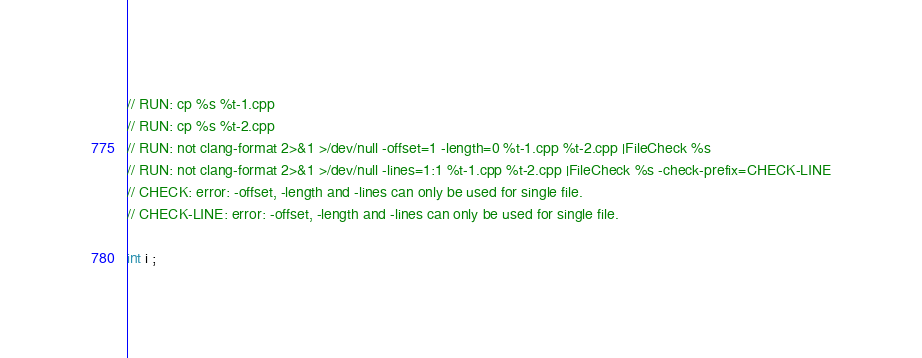Convert code to text. <code><loc_0><loc_0><loc_500><loc_500><_C++_>// RUN: cp %s %t-1.cpp
// RUN: cp %s %t-2.cpp
// RUN: not clang-format 2>&1 >/dev/null -offset=1 -length=0 %t-1.cpp %t-2.cpp |FileCheck %s
// RUN: not clang-format 2>&1 >/dev/null -lines=1:1 %t-1.cpp %t-2.cpp |FileCheck %s -check-prefix=CHECK-LINE
// CHECK: error: -offset, -length and -lines can only be used for single file.
// CHECK-LINE: error: -offset, -length and -lines can only be used for single file.

int i ;
</code> 